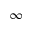<formula> <loc_0><loc_0><loc_500><loc_500>\infty</formula> 